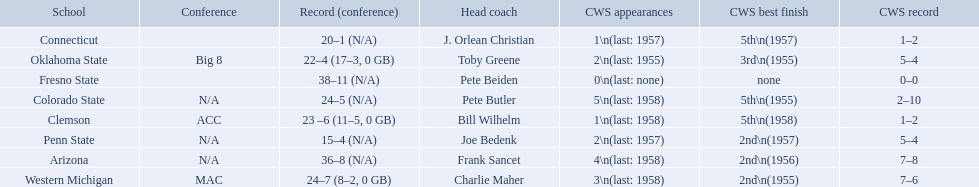What are the listed schools? Arizona, Clemson, Colorado State, Connecticut, Fresno State, Oklahoma State, Penn State, Western Michigan. Which are clemson and western michigan? Clemson, Western Michigan. What are their corresponding numbers of cws appearances? 1\n(last: 1958), 3\n(last: 1958). Which value is larger? 3\n(last: 1958). To which school does that value belong to? Western Michigan. 